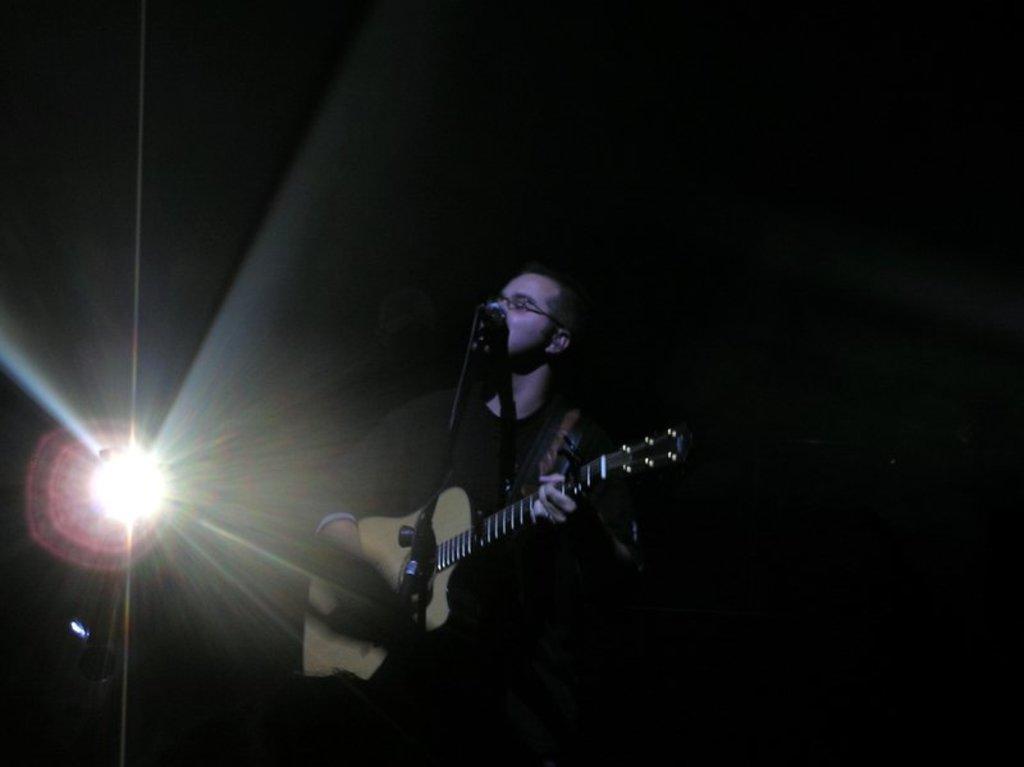In one or two sentences, can you explain what this image depicts? There is a guy standing here, holding a guitar in his hand, in front of the microphone and stand. Behind him there is a light. 